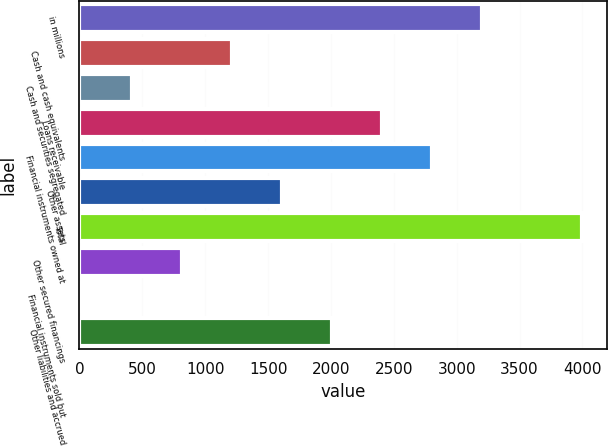<chart> <loc_0><loc_0><loc_500><loc_500><bar_chart><fcel>in millions<fcel>Cash and cash equivalents<fcel>Cash and securities segregated<fcel>Loans receivable<fcel>Financial instruments owned at<fcel>Other assets<fcel>Total<fcel>Other secured financings<fcel>Financial instruments sold but<fcel>Other liabilities and accrued<nl><fcel>3202.4<fcel>1210.9<fcel>414.3<fcel>2405.8<fcel>2804.1<fcel>1609.2<fcel>3999<fcel>812.6<fcel>16<fcel>2007.5<nl></chart> 